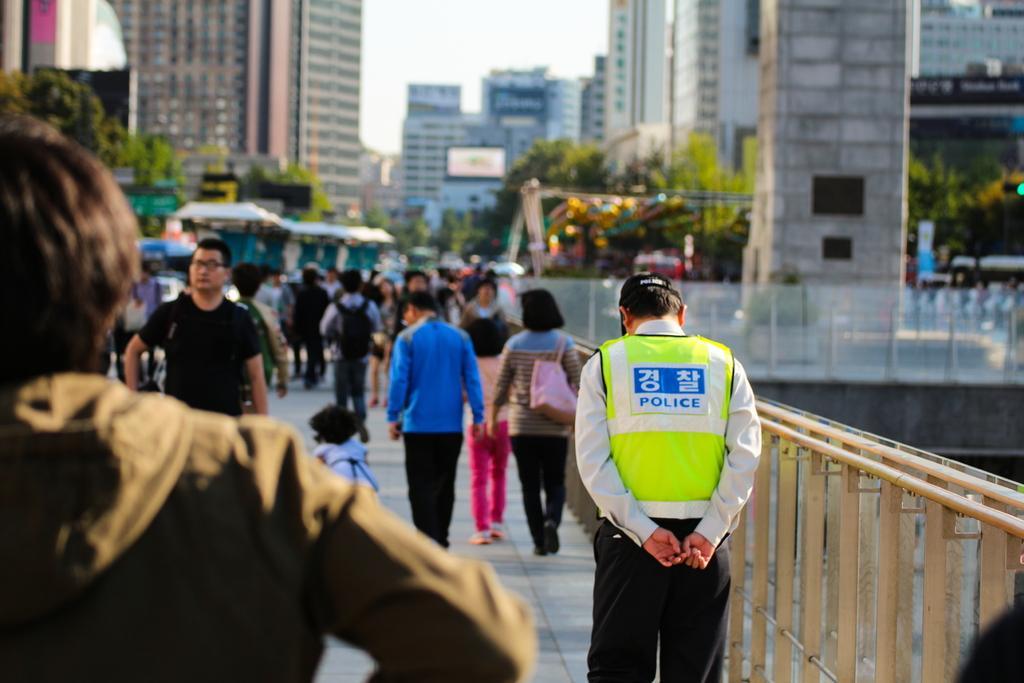Can you describe this image briefly? In this image we can see group of persons standing on the ground. One person wearing police coat and a cap is standing beside a metal railing. One woman is carrying a bag. In the foreground we can see a person wearing a brown coat. In the background, we can see a group of trees, buildings and sky. 